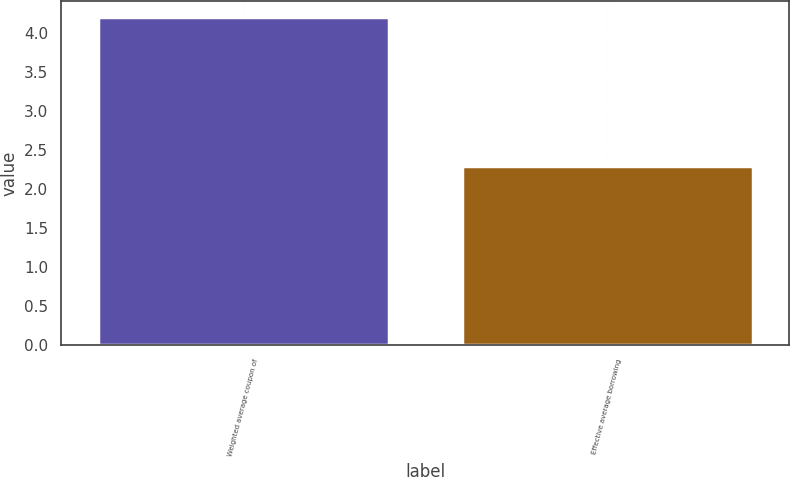<chart> <loc_0><loc_0><loc_500><loc_500><bar_chart><fcel>Weighted average coupon of<fcel>Effective average borrowing<nl><fcel>4.2<fcel>2.3<nl></chart> 